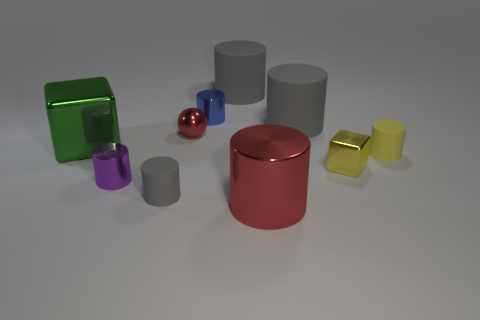How many gray cylinders must be subtracted to get 1 gray cylinders? 2 Subtract all brown balls. How many gray cylinders are left? 3 Subtract all red cylinders. How many cylinders are left? 6 Subtract all small purple cylinders. How many cylinders are left? 6 Subtract all yellow cylinders. Subtract all red cubes. How many cylinders are left? 6 Subtract all cubes. How many objects are left? 8 Add 5 red metallic objects. How many red metallic objects exist? 7 Subtract 0 blue cubes. How many objects are left? 10 Subtract all large gray rubber cylinders. Subtract all purple metallic objects. How many objects are left? 7 Add 4 metallic cylinders. How many metallic cylinders are left? 7 